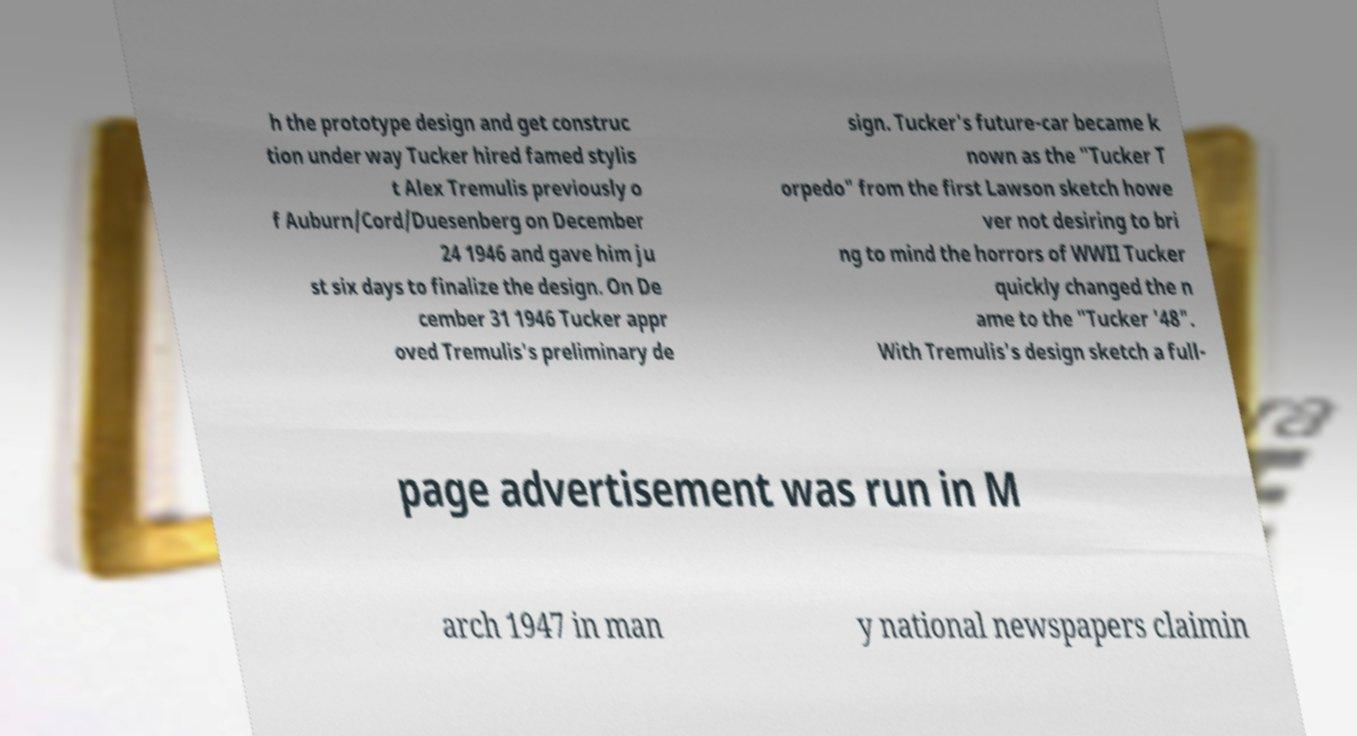Can you accurately transcribe the text from the provided image for me? h the prototype design and get construc tion under way Tucker hired famed stylis t Alex Tremulis previously o f Auburn/Cord/Duesenberg on December 24 1946 and gave him ju st six days to finalize the design. On De cember 31 1946 Tucker appr oved Tremulis's preliminary de sign. Tucker's future-car became k nown as the "Tucker T orpedo" from the first Lawson sketch howe ver not desiring to bri ng to mind the horrors of WWII Tucker quickly changed the n ame to the "Tucker '48". With Tremulis's design sketch a full- page advertisement was run in M arch 1947 in man y national newspapers claimin 